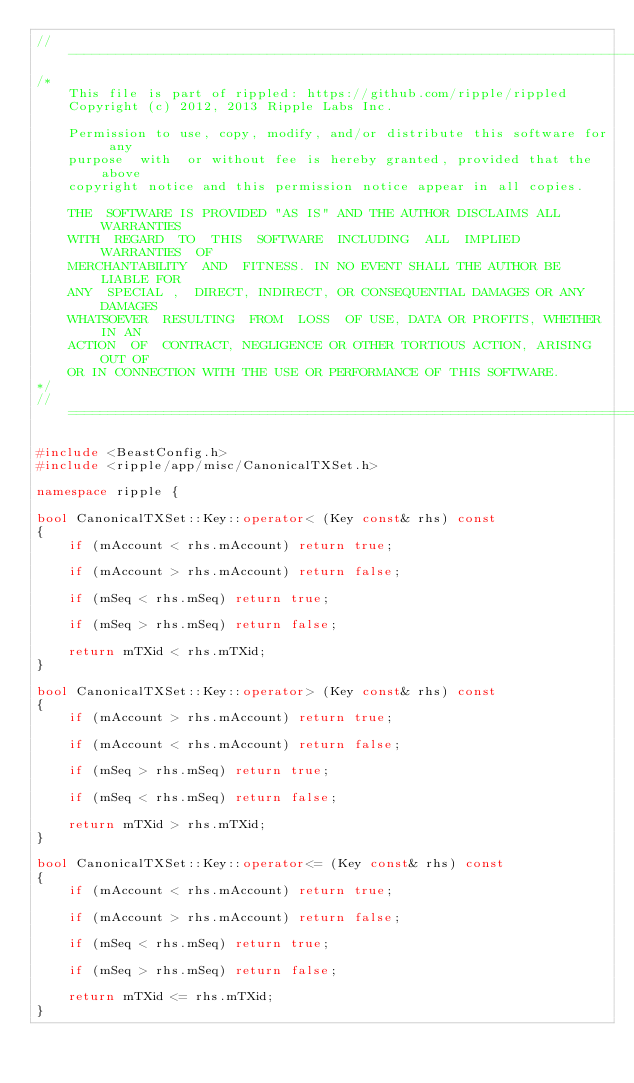<code> <loc_0><loc_0><loc_500><loc_500><_C++_>//------------------------------------------------------------------------------
/*
    This file is part of rippled: https://github.com/ripple/rippled
    Copyright (c) 2012, 2013 Ripple Labs Inc.

    Permission to use, copy, modify, and/or distribute this software for any
    purpose  with  or without fee is hereby granted, provided that the above
    copyright notice and this permission notice appear in all copies.

    THE  SOFTWARE IS PROVIDED "AS IS" AND THE AUTHOR DISCLAIMS ALL WARRANTIES
    WITH  REGARD  TO  THIS  SOFTWARE  INCLUDING  ALL  IMPLIED  WARRANTIES  OF
    MERCHANTABILITY  AND  FITNESS. IN NO EVENT SHALL THE AUTHOR BE LIABLE FOR
    ANY  SPECIAL ,  DIRECT, INDIRECT, OR CONSEQUENTIAL DAMAGES OR ANY DAMAGES
    WHATSOEVER  RESULTING  FROM  LOSS  OF USE, DATA OR PROFITS, WHETHER IN AN
    ACTION  OF  CONTRACT, NEGLIGENCE OR OTHER TORTIOUS ACTION, ARISING OUT OF
    OR IN CONNECTION WITH THE USE OR PERFORMANCE OF THIS SOFTWARE.
*/
//==============================================================================

#include <BeastConfig.h>
#include <ripple/app/misc/CanonicalTXSet.h>

namespace ripple {

bool CanonicalTXSet::Key::operator< (Key const& rhs) const
{
    if (mAccount < rhs.mAccount) return true;

    if (mAccount > rhs.mAccount) return false;

    if (mSeq < rhs.mSeq) return true;

    if (mSeq > rhs.mSeq) return false;

    return mTXid < rhs.mTXid;
}

bool CanonicalTXSet::Key::operator> (Key const& rhs) const
{
    if (mAccount > rhs.mAccount) return true;

    if (mAccount < rhs.mAccount) return false;

    if (mSeq > rhs.mSeq) return true;

    if (mSeq < rhs.mSeq) return false;

    return mTXid > rhs.mTXid;
}

bool CanonicalTXSet::Key::operator<= (Key const& rhs) const
{
    if (mAccount < rhs.mAccount) return true;

    if (mAccount > rhs.mAccount) return false;

    if (mSeq < rhs.mSeq) return true;

    if (mSeq > rhs.mSeq) return false;

    return mTXid <= rhs.mTXid;
}
</code> 